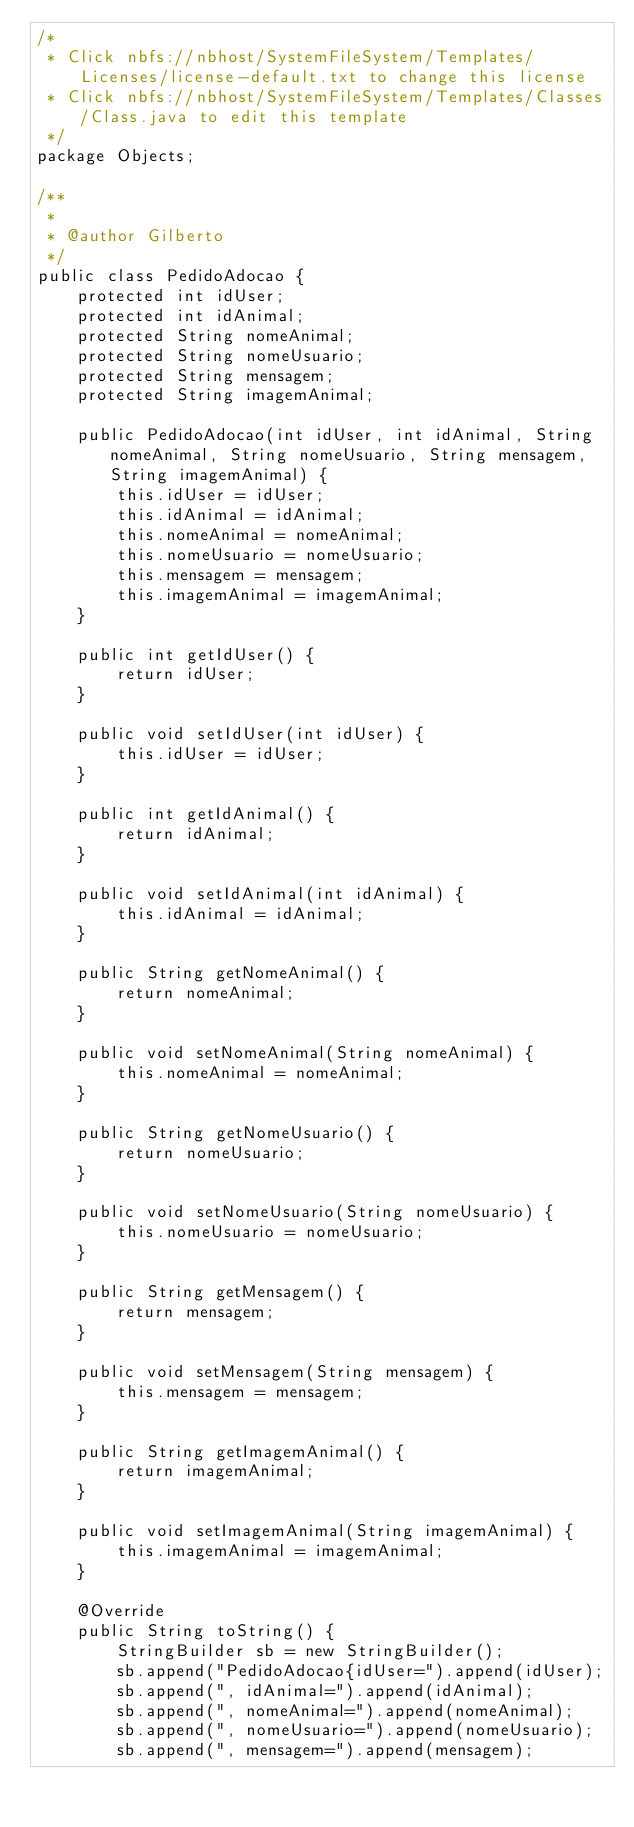Convert code to text. <code><loc_0><loc_0><loc_500><loc_500><_Java_>/*
 * Click nbfs://nbhost/SystemFileSystem/Templates/Licenses/license-default.txt to change this license
 * Click nbfs://nbhost/SystemFileSystem/Templates/Classes/Class.java to edit this template
 */
package Objects;

/**
 *
 * @author Gilberto
 */
public class PedidoAdocao {
    protected int idUser;
    protected int idAnimal;
    protected String nomeAnimal;
    protected String nomeUsuario;
    protected String mensagem;
    protected String imagemAnimal;

    public PedidoAdocao(int idUser, int idAnimal, String nomeAnimal, String nomeUsuario, String mensagem, String imagemAnimal) {
        this.idUser = idUser;
        this.idAnimal = idAnimal;
        this.nomeAnimal = nomeAnimal;
        this.nomeUsuario = nomeUsuario;
        this.mensagem = mensagem;
        this.imagemAnimal = imagemAnimal;
    }

    public int getIdUser() {
        return idUser;
    }

    public void setIdUser(int idUser) {
        this.idUser = idUser;
    }

    public int getIdAnimal() {
        return idAnimal;
    }

    public void setIdAnimal(int idAnimal) {
        this.idAnimal = idAnimal;
    }

    public String getNomeAnimal() {
        return nomeAnimal;
    }

    public void setNomeAnimal(String nomeAnimal) {
        this.nomeAnimal = nomeAnimal;
    }

    public String getNomeUsuario() {
        return nomeUsuario;
    }

    public void setNomeUsuario(String nomeUsuario) {
        this.nomeUsuario = nomeUsuario;
    }

    public String getMensagem() {
        return mensagem;
    }

    public void setMensagem(String mensagem) {
        this.mensagem = mensagem;
    }

    public String getImagemAnimal() {
        return imagemAnimal;
    }

    public void setImagemAnimal(String imagemAnimal) {
        this.imagemAnimal = imagemAnimal;
    }

    @Override
    public String toString() {
        StringBuilder sb = new StringBuilder();
        sb.append("PedidoAdocao{idUser=").append(idUser);
        sb.append(", idAnimal=").append(idAnimal);
        sb.append(", nomeAnimal=").append(nomeAnimal);
        sb.append(", nomeUsuario=").append(nomeUsuario);
        sb.append(", mensagem=").append(mensagem);</code> 